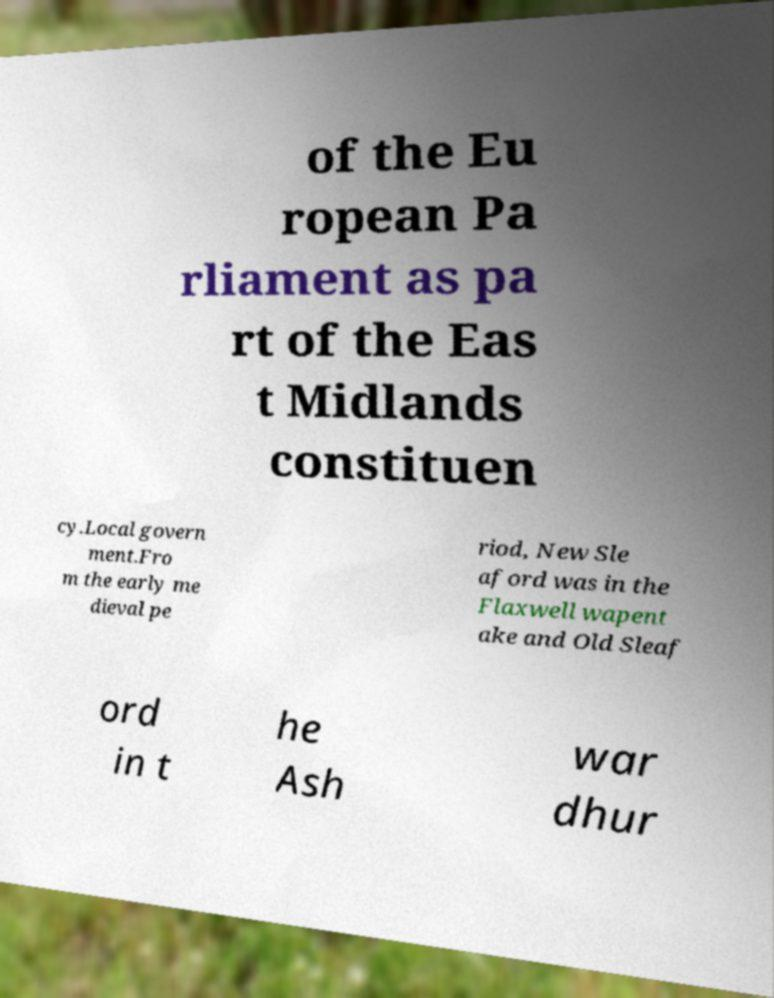There's text embedded in this image that I need extracted. Can you transcribe it verbatim? of the Eu ropean Pa rliament as pa rt of the Eas t Midlands constituen cy.Local govern ment.Fro m the early me dieval pe riod, New Sle aford was in the Flaxwell wapent ake and Old Sleaf ord in t he Ash war dhur 